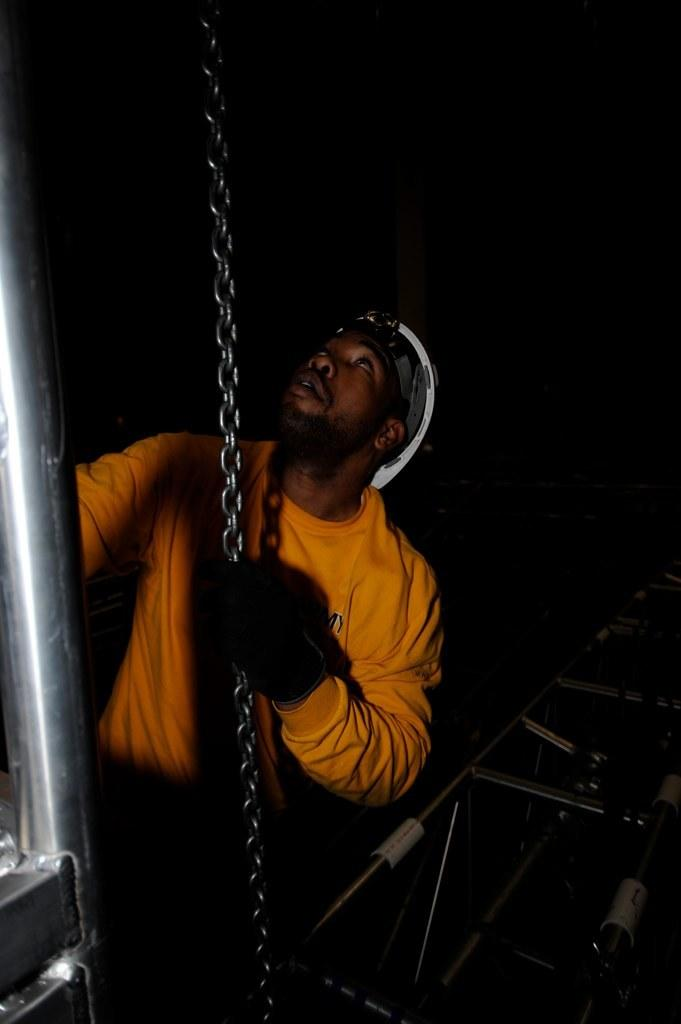Who is the main subject in the image? There is a man in the image. What is the man wearing? The man is wearing a yellow t-shirt. What is the man holding in the image? The man is holding a chain. What can be observed about the background of the image? The background of the image is dark. What route is the maid taking in the image? There is no maid present in the image, so it is not possible to determine a route. 